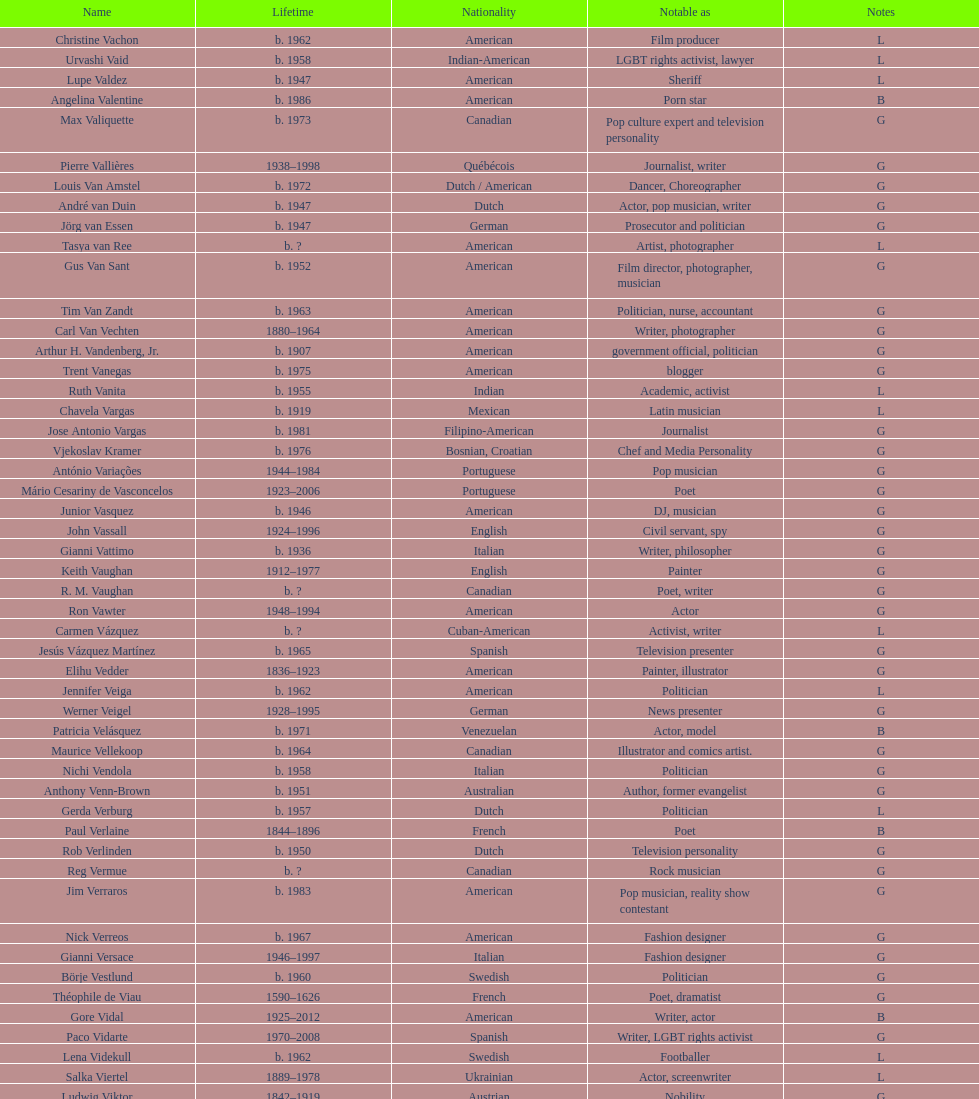Between van amstel and valiquette, who hailed from canada? Valiquette. 